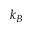<formula> <loc_0><loc_0><loc_500><loc_500>k _ { B }</formula> 